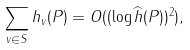Convert formula to latex. <formula><loc_0><loc_0><loc_500><loc_500>\sum _ { v \in S } h _ { v } ( P ) = O ( ( \log \widehat { h } ( P ) ) ^ { 2 } ) ,</formula> 